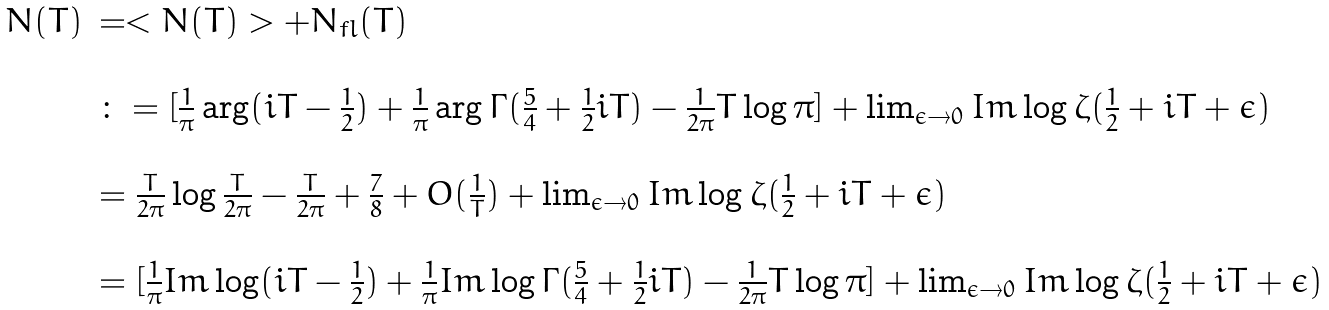Convert formula to latex. <formula><loc_0><loc_0><loc_500><loc_500>\begin{array} { r l } N ( T ) & = < N ( T ) > + N _ { f l } ( T ) \\ \\ & \colon = [ \frac { 1 } { \pi } \arg ( i T - \frac { 1 } { 2 } ) + \frac { 1 } { \pi } \arg \Gamma ( \frac { 5 } { 4 } + \frac { 1 } { 2 } i T ) - \frac { 1 } { 2 \pi } T \log \pi ] + \lim _ { \epsilon \to 0 } I m \log \zeta ( \frac { 1 } { 2 } + i T + \epsilon ) \\ \\ & = \frac { T } { 2 \pi } \log \frac { T } { 2 \pi } - \frac { T } { 2 \pi } + \frac { 7 } { 8 } + O ( \frac { 1 } { T } ) + \lim _ { \epsilon \to 0 } I m \log \zeta ( \frac { 1 } { 2 } + i T + \epsilon ) \\ \\ & = [ \frac { 1 } { \pi } I m \log ( i T - \frac { 1 } { 2 } ) + \frac { 1 } { \pi } I m \log \Gamma ( \frac { 5 } { 4 } + \frac { 1 } { 2 } i T ) - \frac { 1 } { 2 \pi } T \log \pi ] + \lim _ { \epsilon \to 0 } I m \log \zeta ( \frac { 1 } { 2 } + i T + \epsilon ) \end{array}</formula> 